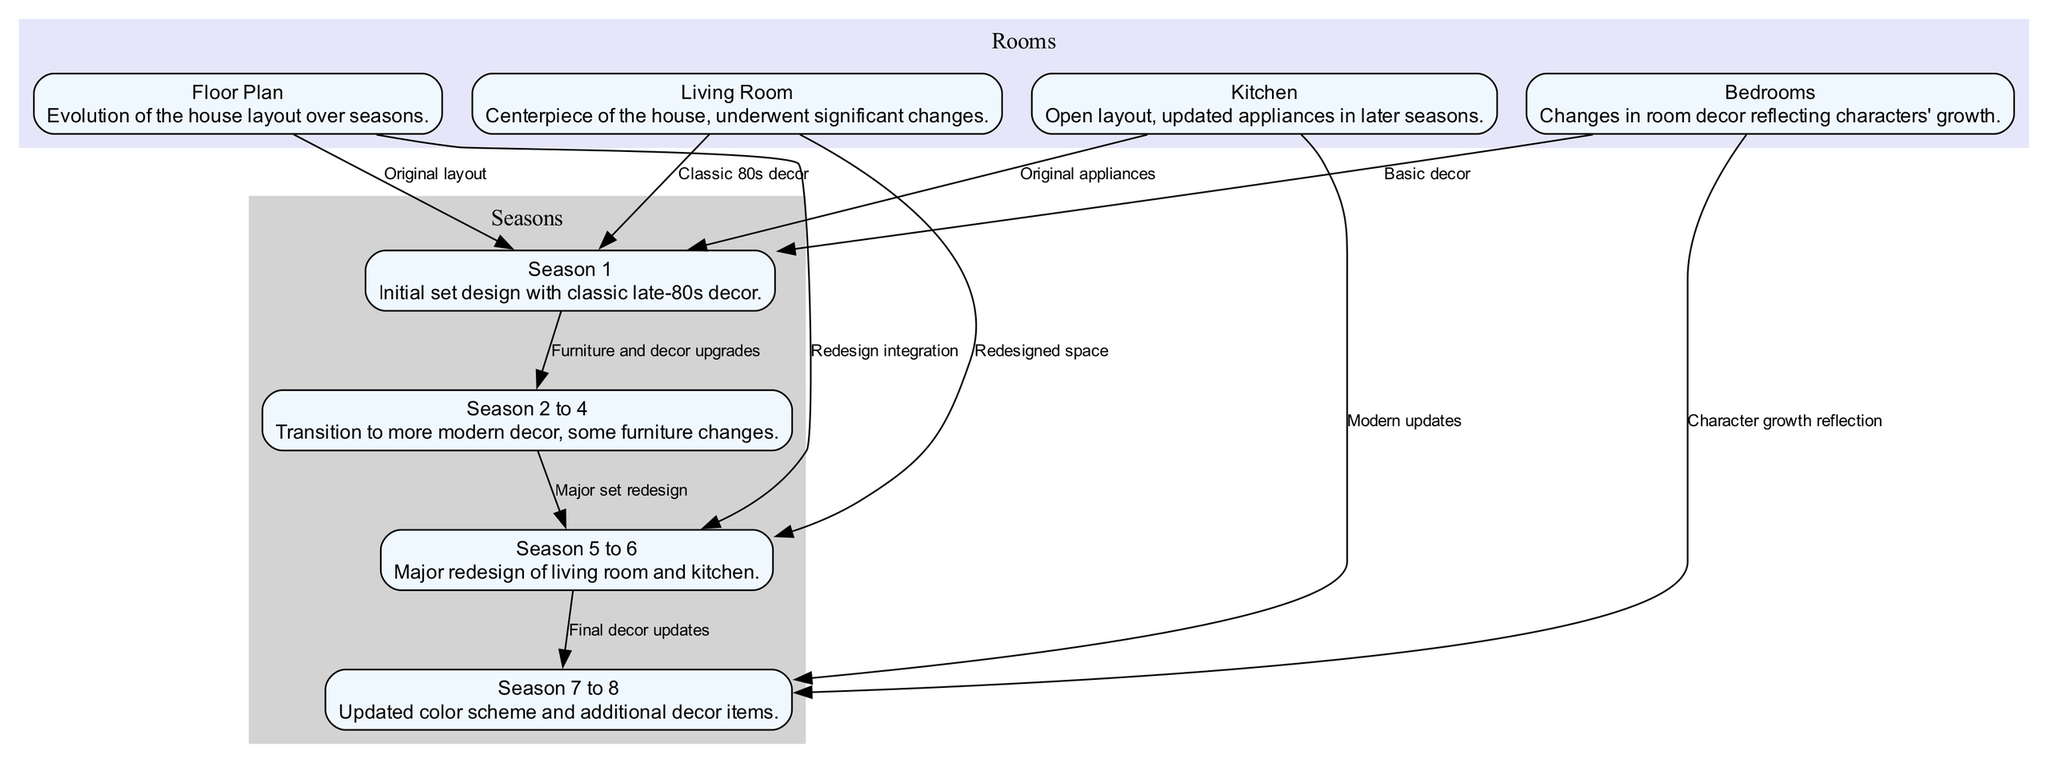What is the initial set design description in Season 1? The node for Season 1 states the initial set design with classic late-80s decor. This is directly provided in the node's description.
Answer: Initial set design with classic late-80s decor How many seasons showed a major redesign of the living room and kitchen? The edges detail that there is a major set redesign transitioning from Season 2 to 4 to Season 5 to 6. There is only one significant redesign mentioned between these seasons.
Answer: 1 In which seasons did the kitchen have an updated design? The diagram connects the kitchen node to both Season 1 (original appliances) and Season 7 to 8 (modern updates). This shows two periods of design, but only the later seasons indicate a modern update.
Answer: Season 7 to 8 What change is indicated in the bedrooms from Season 1 to Season 7 to 8? The bedrooms show a transition from basic decor in Season 1 to decor that reflects character growth in Season 7 to 8, as indicated by edges connecting these nodes.
Answer: Character growth reflection Which set areas saw their decor significantly evolve from Season 5 to Season 6? The diagram presents edges connecting the living room and kitchen to the Seasons 5 to 6 node, suggesting that these areas underwent significant change during this time.
Answer: Living room and kitchen What is the relationship between floor plans and Season 1? The edge from the floor plan node to the Season 1 node indicates that the original layout is described as part of the initial design specifications of the house.
Answer: Original layout How many nodes represent the seasons in this diagram? The seasons are represented by four nodes: Season 1, Seasons 2 to 4, Seasons 5 to 6, and Seasons 7 to 8. Counting these nodes gives a total of four distinct representations.
Answer: 4 What does the edge connecting Season 5 to 6 imply about set changes? This edge labeled "Major set redesign" signifies that during the transition from Season 2 to 4 to Seasons 5 to 6, considerable changes were made to the set's design, particularly in the living room and kitchen areas.
Answer: Major set redesign 